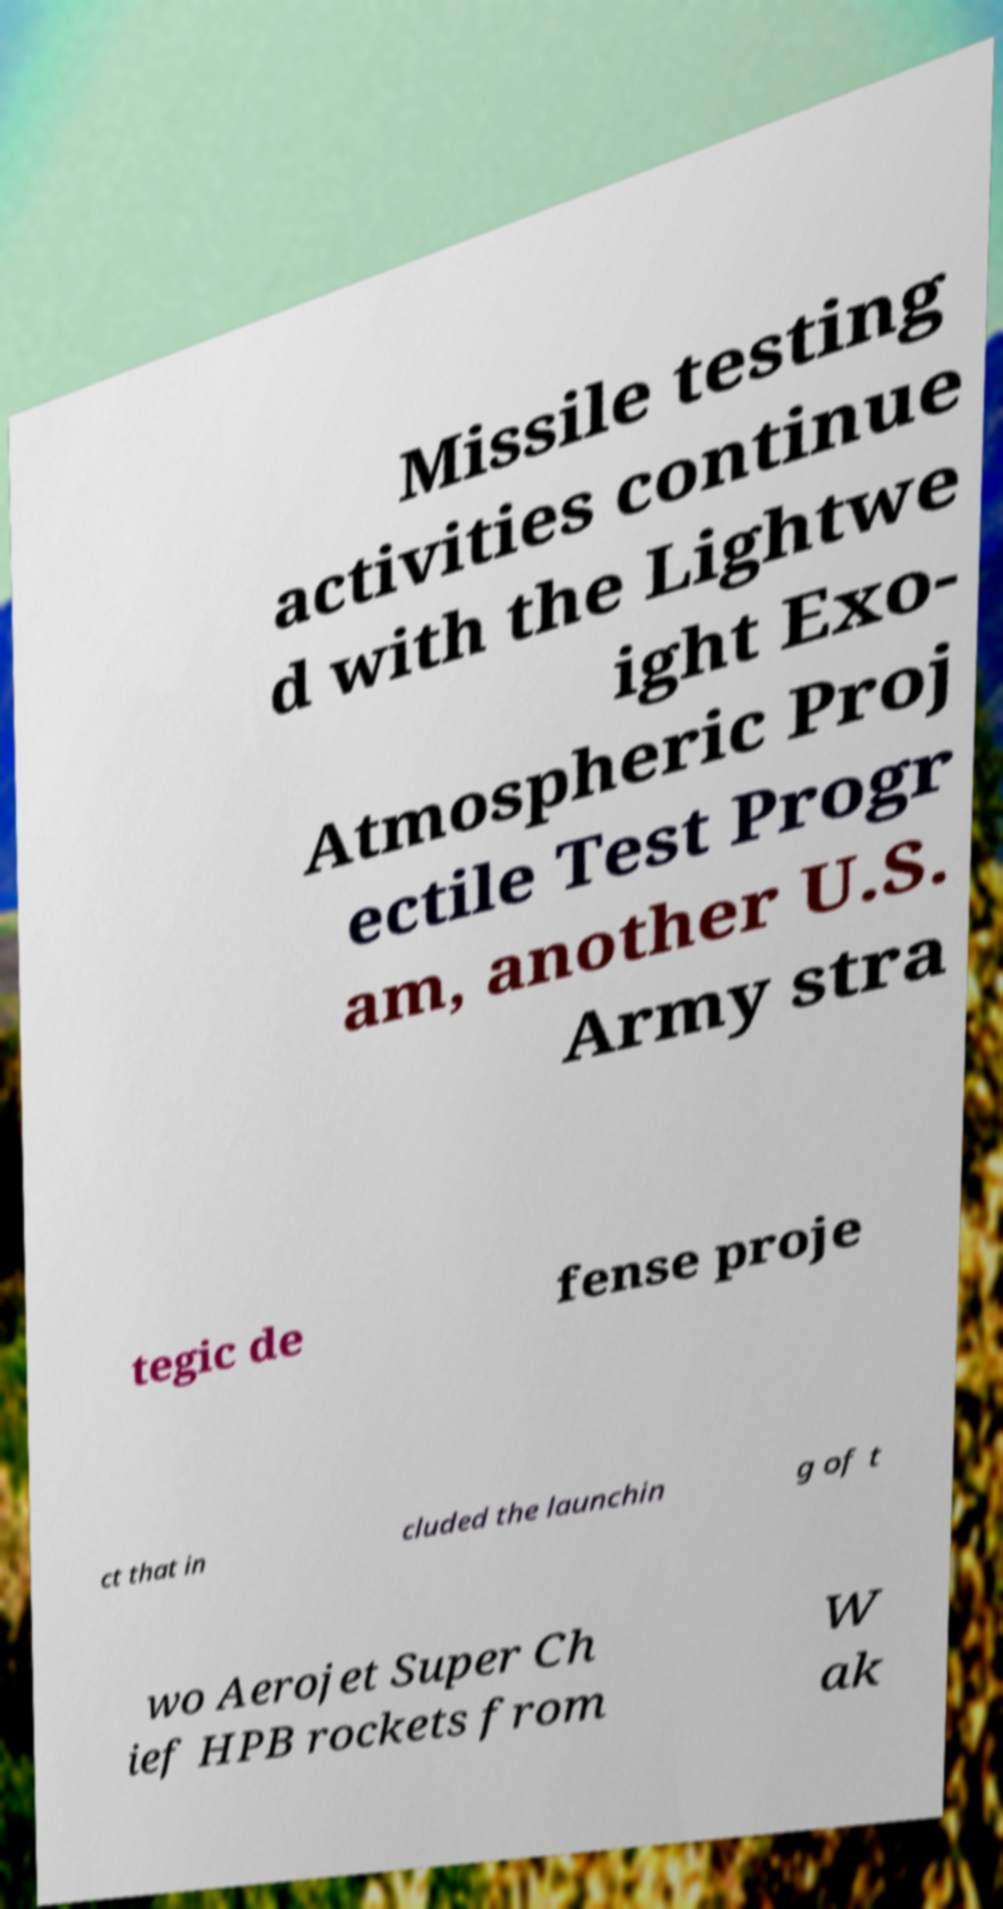Please read and relay the text visible in this image. What does it say? Missile testing activities continue d with the Lightwe ight Exo- Atmospheric Proj ectile Test Progr am, another U.S. Army stra tegic de fense proje ct that in cluded the launchin g of t wo Aerojet Super Ch ief HPB rockets from W ak 